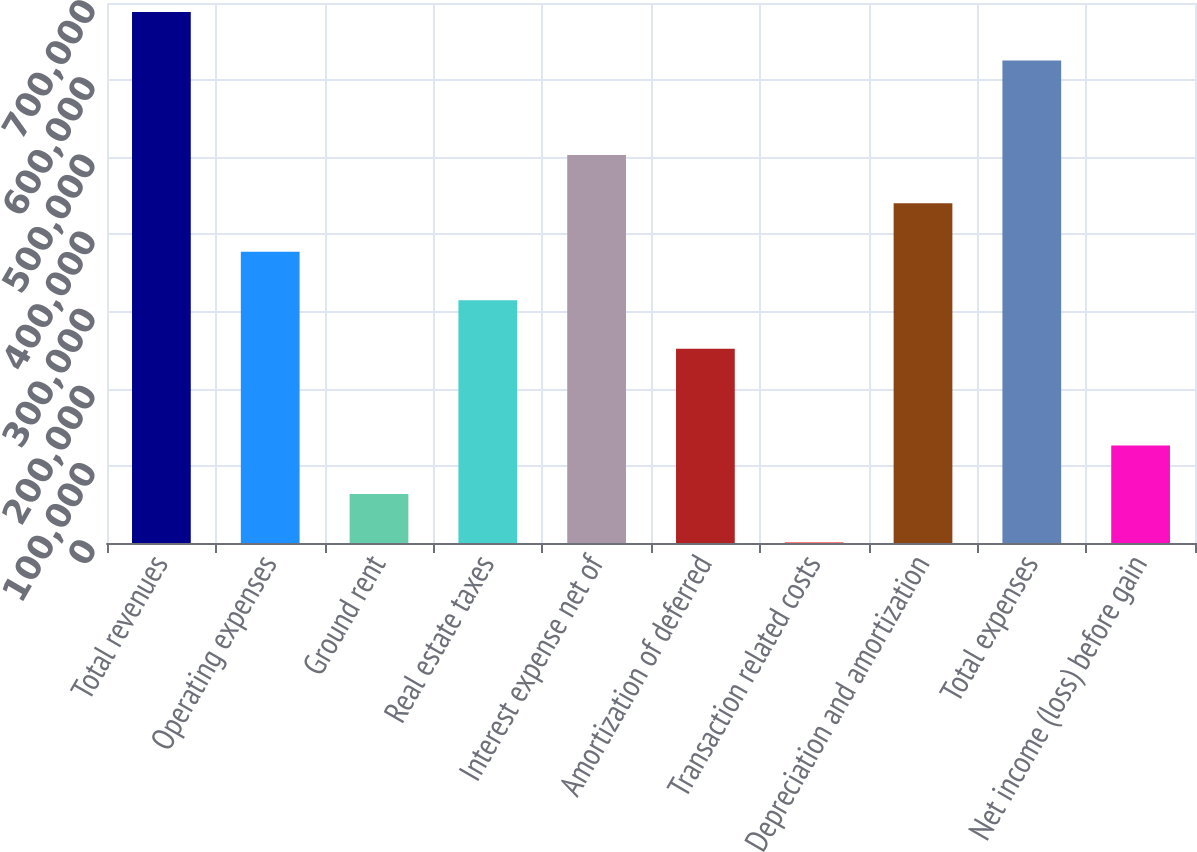Convert chart to OTSL. <chart><loc_0><loc_0><loc_500><loc_500><bar_chart><fcel>Total revenues<fcel>Operating expenses<fcel>Ground rent<fcel>Real estate taxes<fcel>Interest expense net of<fcel>Amortization of deferred<fcel>Transaction related costs<fcel>Depreciation and amortization<fcel>Total expenses<fcel>Net income (loss) before gain<nl><fcel>688204<fcel>377513<fcel>63592.1<fcel>314728<fcel>503081<fcel>251944<fcel>808<fcel>440297<fcel>625420<fcel>126376<nl></chart> 